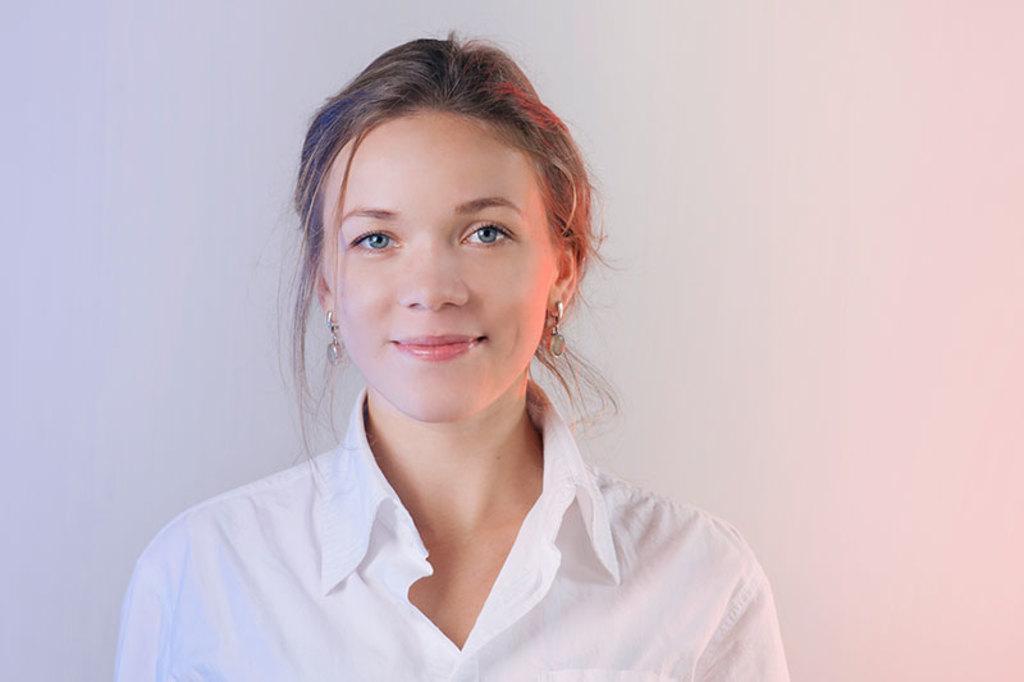Can you describe this image briefly? This image consists of a woman. She is wearing a white dress and earrings. She is smiling. 